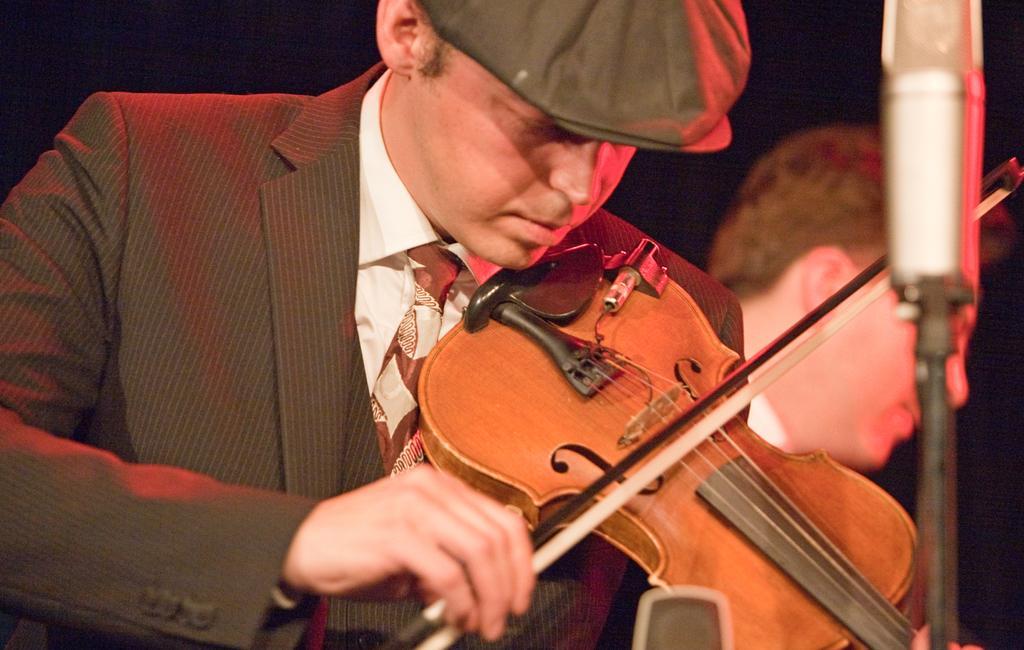How would you summarize this image in a sentence or two? In this image we can see two people, a person is playing a violin and in front of the person there is a mic. 